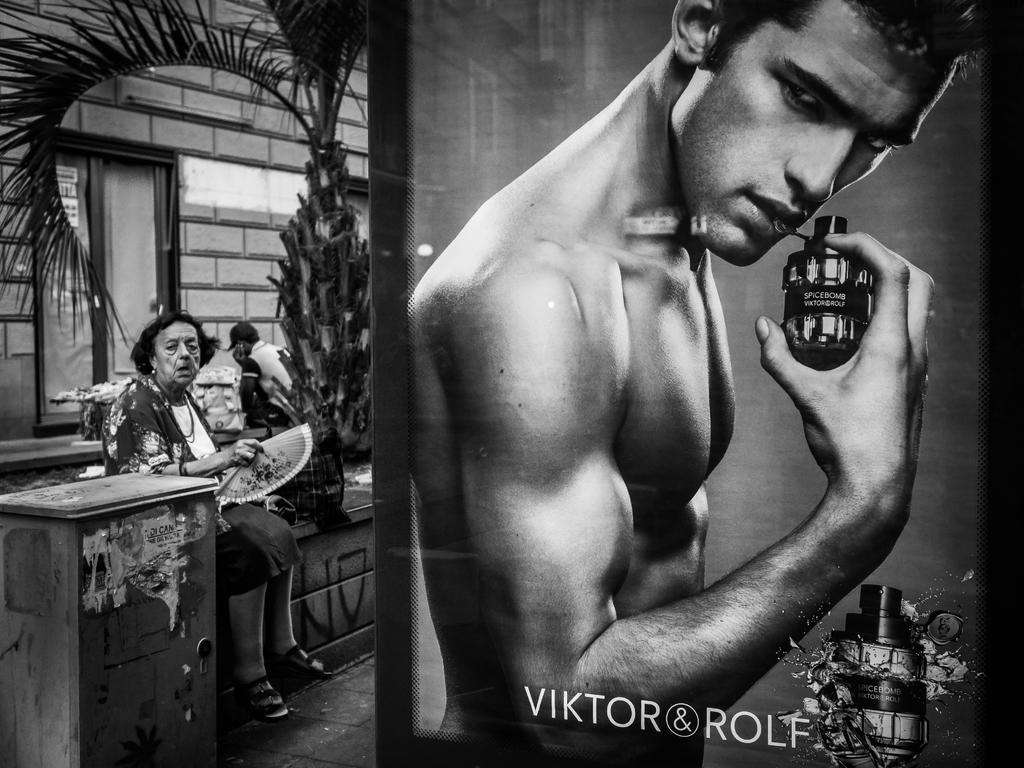Could you give a brief overview of what you see in this image? In this image there are two persons on the left side of this image and there is a building in the background and there is a tree in middle of this image, and there is one person's picture on the right side of this image, and there is some text written in the bottom of this image. 